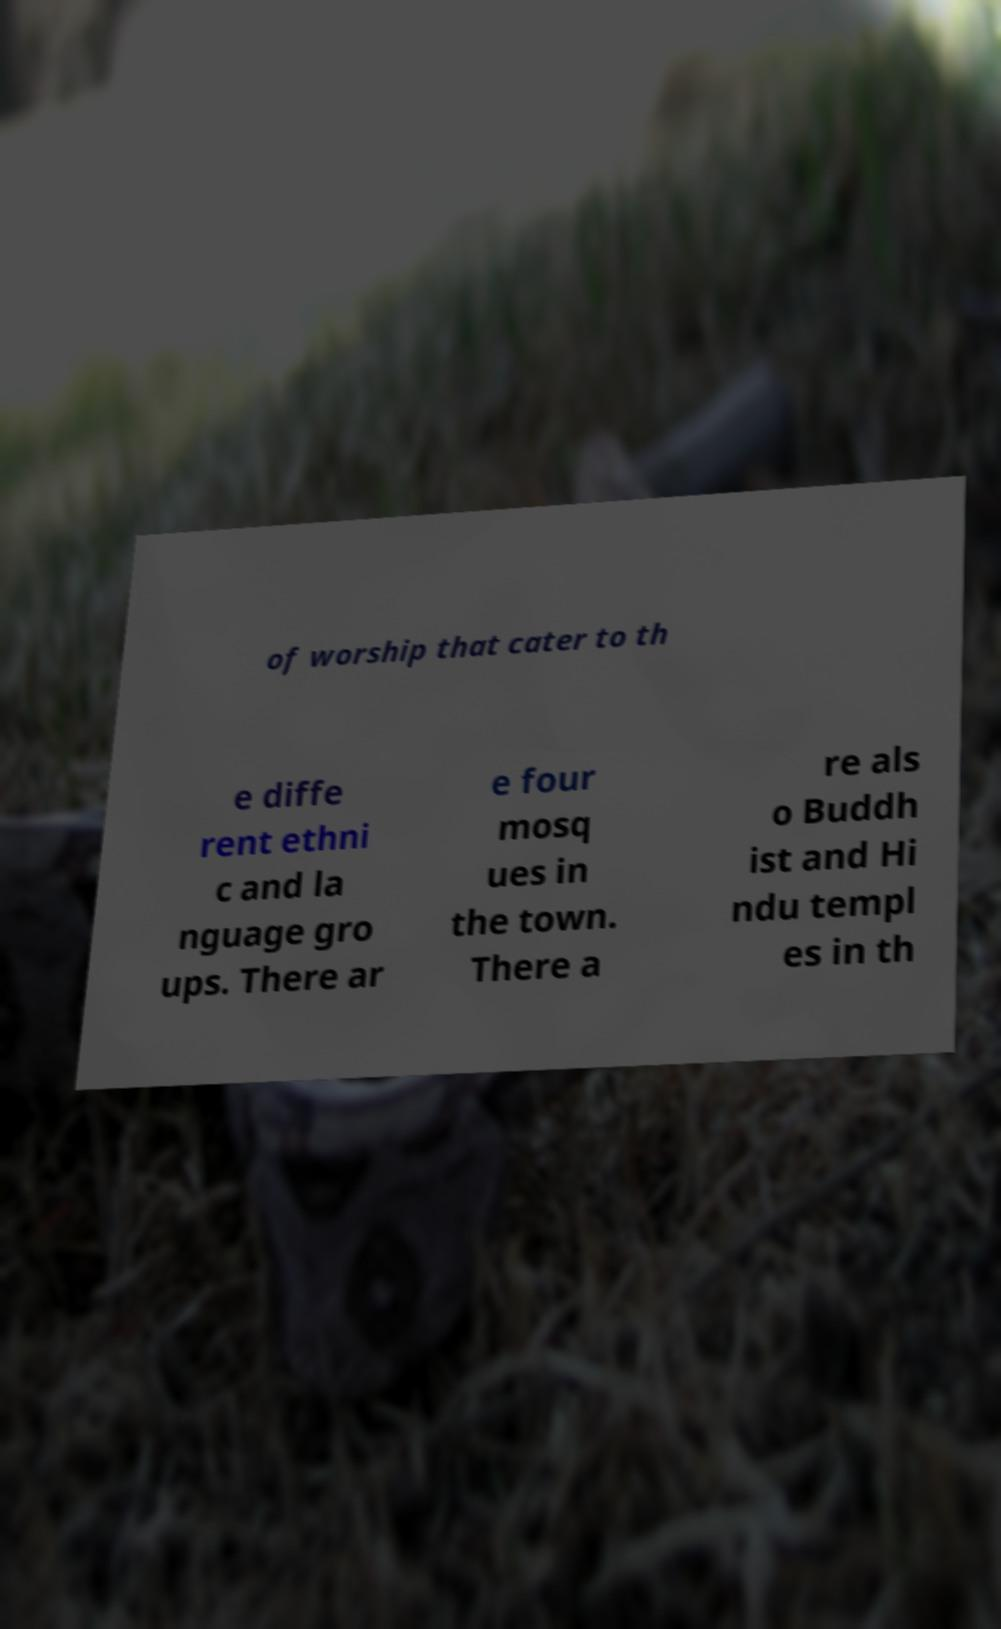Please read and relay the text visible in this image. What does it say? of worship that cater to th e diffe rent ethni c and la nguage gro ups. There ar e four mosq ues in the town. There a re als o Buddh ist and Hi ndu templ es in th 